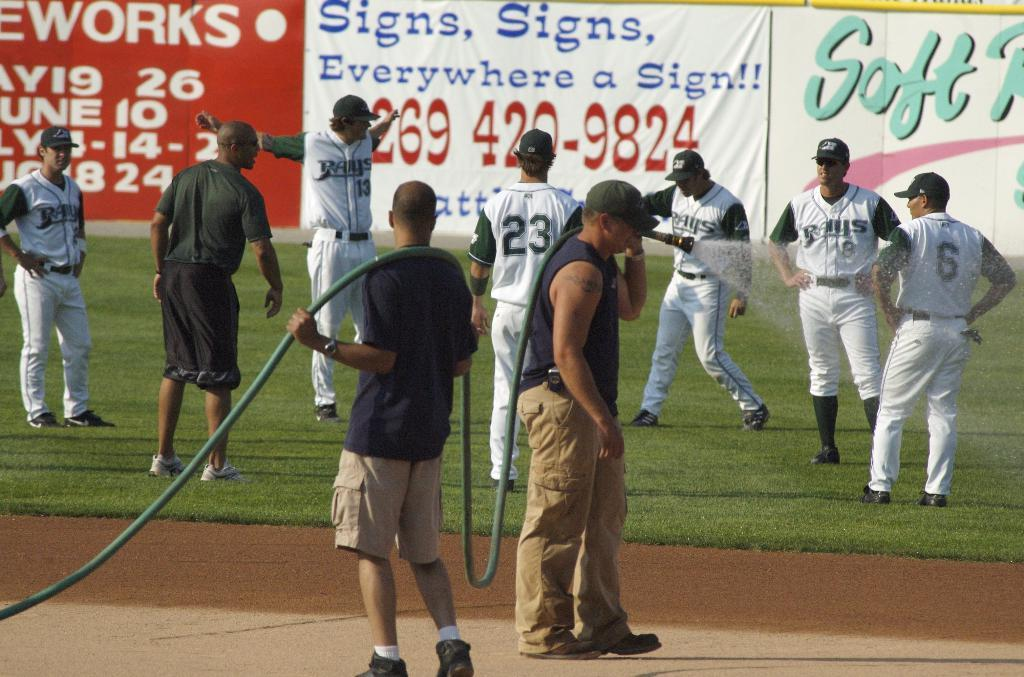<image>
Relay a brief, clear account of the picture shown. A banner about sign advertising is hanging in the outfield. 